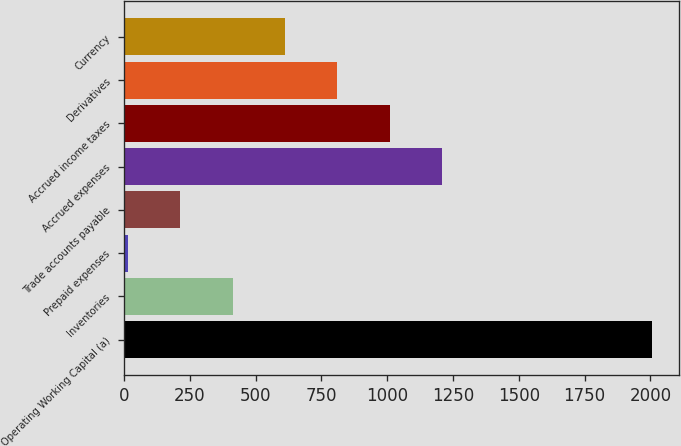Convert chart to OTSL. <chart><loc_0><loc_0><loc_500><loc_500><bar_chart><fcel>Operating Working Capital (a)<fcel>Inventories<fcel>Prepaid expenses<fcel>Trade accounts payable<fcel>Accrued expenses<fcel>Accrued income taxes<fcel>Derivatives<fcel>Currency<nl><fcel>2008<fcel>412<fcel>13<fcel>212.5<fcel>1210<fcel>1010.5<fcel>811<fcel>611.5<nl></chart> 